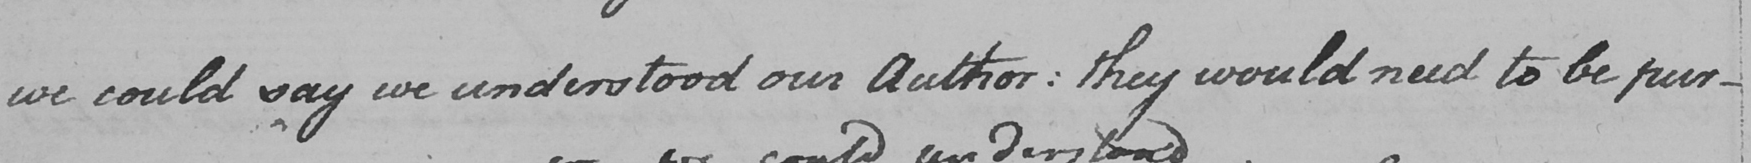Please provide the text content of this handwritten line. we could say we understood our Author :  they would need to be pur- 